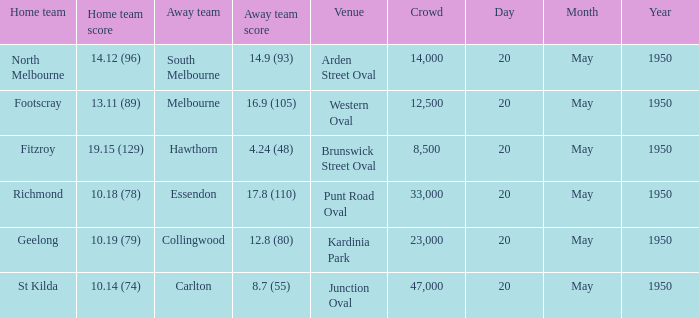What was the largest crowd to view a game where the away team scored 17.8 (110)? 33000.0. 